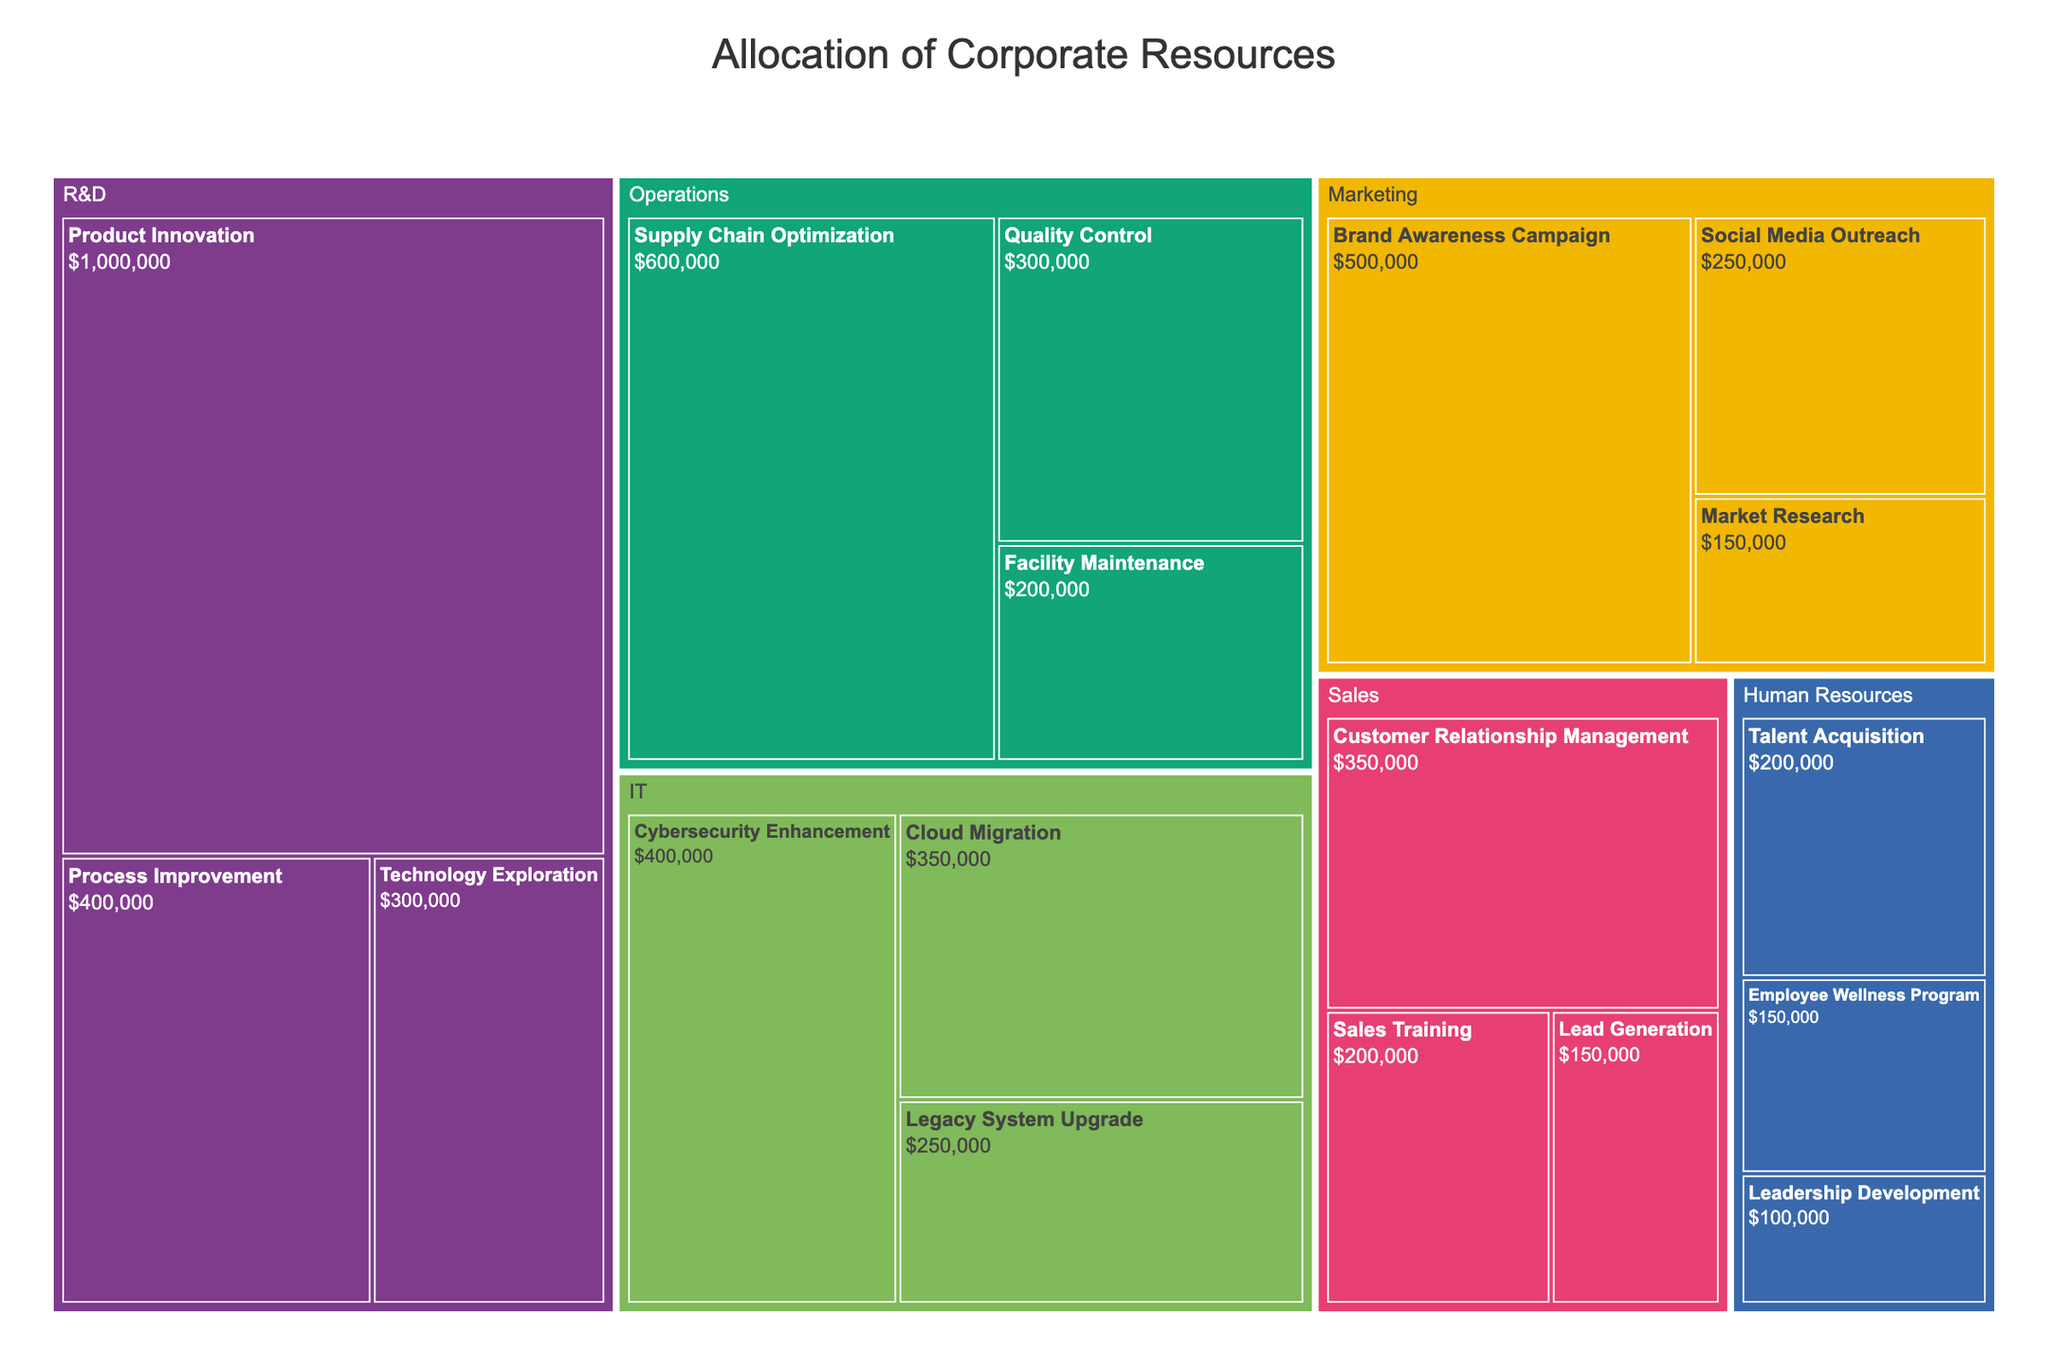What is the total budget allocated to the Marketing department? To find the total budget for the Marketing department, sum the budget values of its projects: Brand Awareness Campaign ($500,000), Social Media Outreach ($250,000), and Market Research ($150,000). The total is $500,000 + $250,000 + $150,000 = $900,000.
Answer: $900,000 Which department has the highest allocated budget? Review the treemap for each department's total budget. The R&D department has the largest budgets for its projects: Product Innovation ($1,000,000), Process Improvement ($400,000), and Technology Exploration ($300,000). Summing these gives $1,700,000, which is the highest among all departments.
Answer: R&D What is the total budget allocated to IT-related projects? Sum the budgets of all IT projects: Cybersecurity Enhancement ($400,000), Cloud Migration ($350,000), and Legacy System Upgrade ($250,000). The total is $400,000 + $350,000 + $250,000 = $1,000,000.
Answer: $1,000,000 Compare the budgets of Supply Chain Optimization and Facility Maintenance within the Operations department. Which one has the larger budget? Check the budget values for Supply Chain Optimization ($600,000) and Facility Maintenance ($200,000). Since $600,000 is greater than $200,000, Supply Chain Optimization has the larger budget.
Answer: Supply Chain Optimization What is the combined budget allocated to Sales and Human Resources departments? Sum the total budgets of all projects within the Sales and Human Resources departments. Sales: Customer Relationship Management ($350,000), Sales Training ($200,000), Lead Generation ($150,000). Total Sales: $350,000 + $200,000 + $150,000 = $700,000. Human Resources: Employee Wellness Program ($150,000), Talent Acquisition ($200,000), Leadership Development ($100,000). Total HR: $150,000 + $200,000 + $100,000 = $450,000. Combined: $700,000 + $450,000 = $1,150,000.
Answer: $1,150,000 Which project in the Marketing department has the smallest budget? Look for the project with the smallest budget under the Marketing department. Market Research has a budget of $150,000, which is the smallest.
Answer: Market Research Does the budget for Cybersecurity Enhancement exceed the total budget for all projects in the Operations department? First, calculate the total budget for the Operations department: Supply Chain Optimization ($600,000), Quality Control ($300,000), and Facility Maintenance ($200,000). Total Operations: $600,000 + $300,000 + $200,000 = $1,100,000. Compare this with the Cybersecurity Enhancement budget ($400,000). Since $400,000 is less than $1,100,000, the Cybersecurity Enhancement budget does not exceed the total budget for the Operations department.
Answer: No How much more budget is allocated to Product Innovation in comparison to Sales Training? Compare the budgets of Product Innovation ($1,000,000) and Sales Training ($200,000). The difference is $1,000,000 - $200,000 = $800,000.
Answer: $800,000 What is the average budget for projects in the Human Resources department? Calculate the total budget of HR projects and then find the average. Total: Employee Wellness Program ($150,000) + Talent Acquisition ($200,000) + Leadership Development ($100,000) = $450,000. Average: $450,000 / 3 projects = $150,000.
Answer: $150,000 